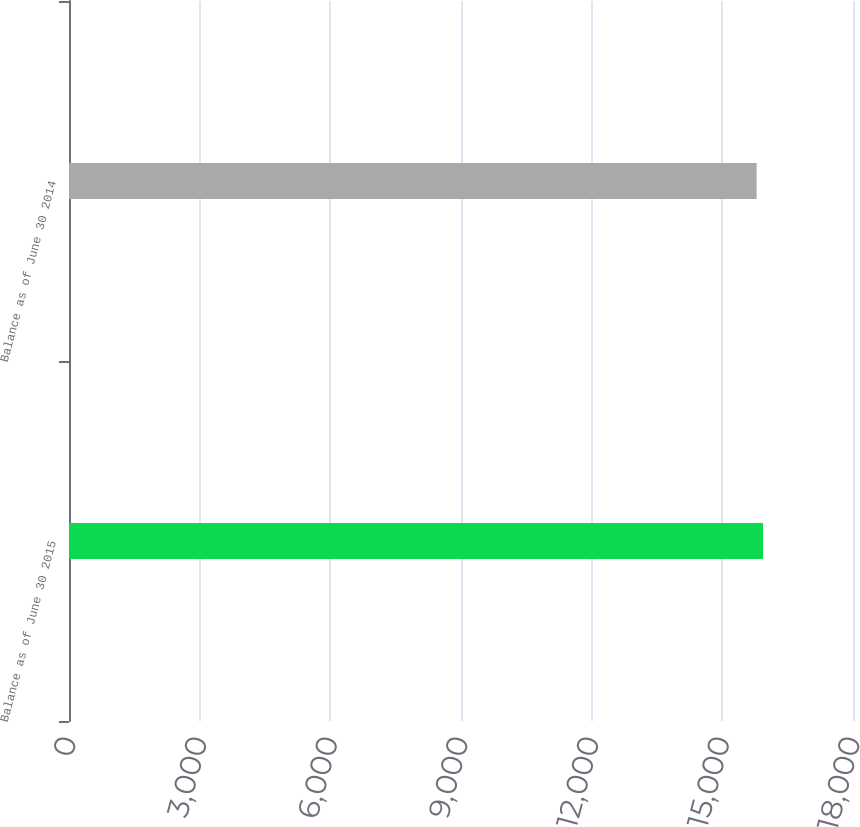Convert chart to OTSL. <chart><loc_0><loc_0><loc_500><loc_500><bar_chart><fcel>Balance as of June 30 2015<fcel>Balance as of June 30 2014<nl><fcel>15935<fcel>15788<nl></chart> 